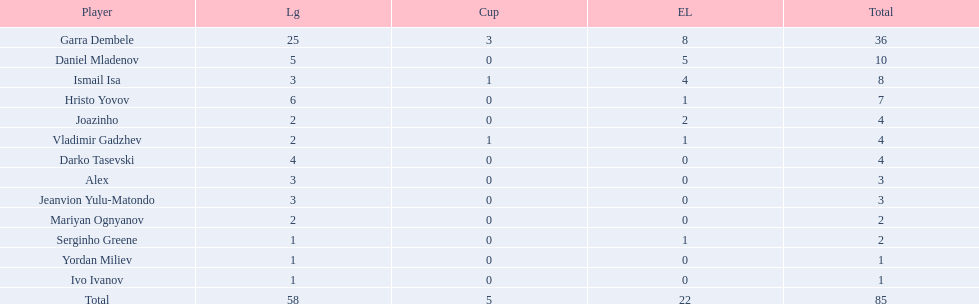Who had the most goal scores? Garra Dembele. 